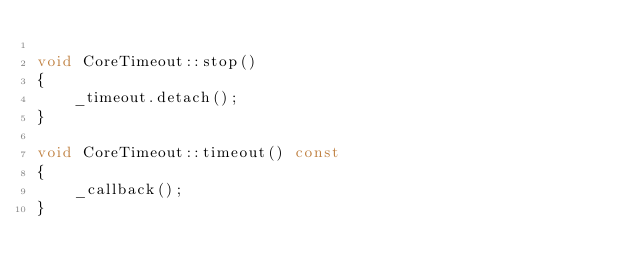Convert code to text. <code><loc_0><loc_0><loc_500><loc_500><_C++_>
void CoreTimeout::stop()
{
	_timeout.detach();
}

void CoreTimeout::timeout() const
{
	_callback();
}
</code> 